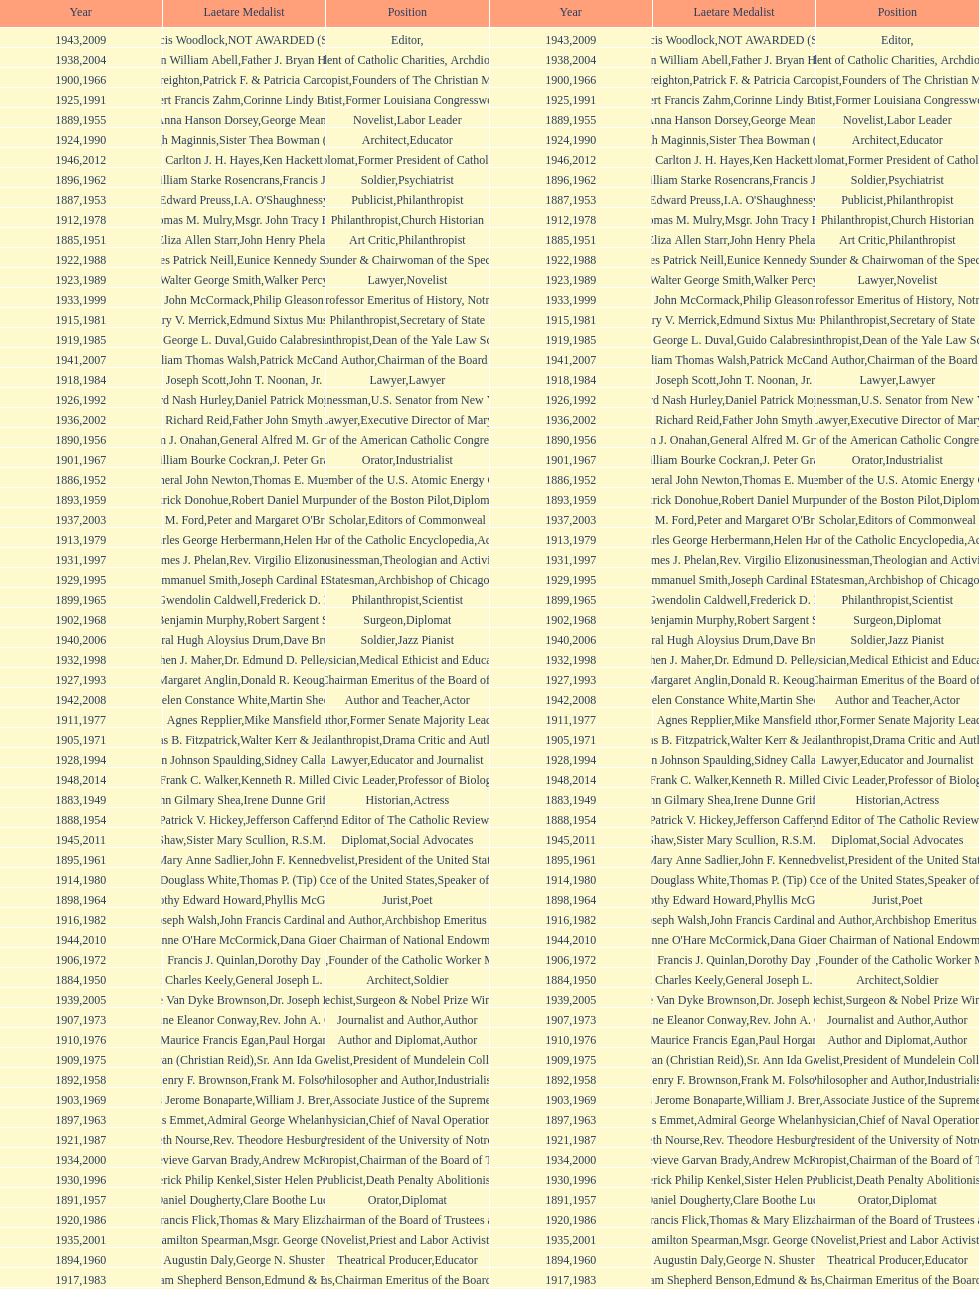Who has won this medal and the nobel prize as well? Dr. Joseph E. Murray. 